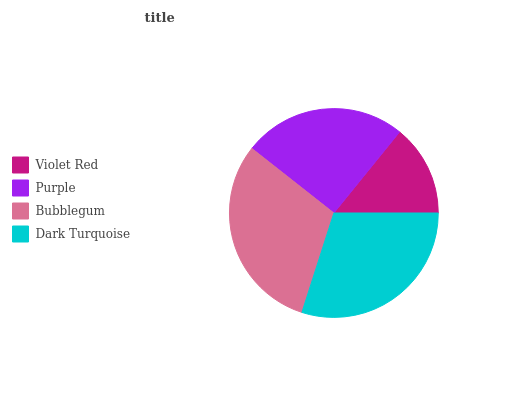Is Violet Red the minimum?
Answer yes or no. Yes. Is Bubblegum the maximum?
Answer yes or no. Yes. Is Purple the minimum?
Answer yes or no. No. Is Purple the maximum?
Answer yes or no. No. Is Purple greater than Violet Red?
Answer yes or no. Yes. Is Violet Red less than Purple?
Answer yes or no. Yes. Is Violet Red greater than Purple?
Answer yes or no. No. Is Purple less than Violet Red?
Answer yes or no. No. Is Dark Turquoise the high median?
Answer yes or no. Yes. Is Purple the low median?
Answer yes or no. Yes. Is Violet Red the high median?
Answer yes or no. No. Is Violet Red the low median?
Answer yes or no. No. 